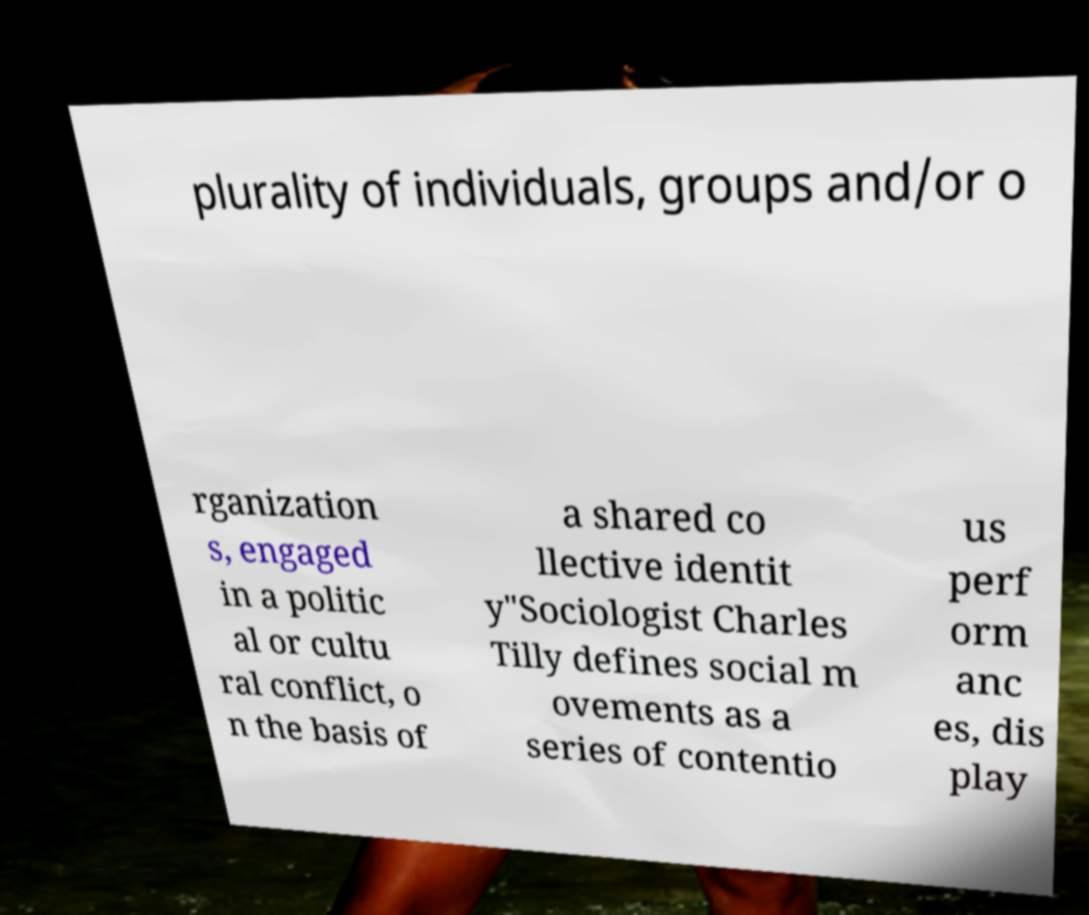Can you accurately transcribe the text from the provided image for me? plurality of individuals, groups and/or o rganization s, engaged in a politic al or cultu ral conflict, o n the basis of a shared co llective identit y"Sociologist Charles Tilly defines social m ovements as a series of contentio us perf orm anc es, dis play 